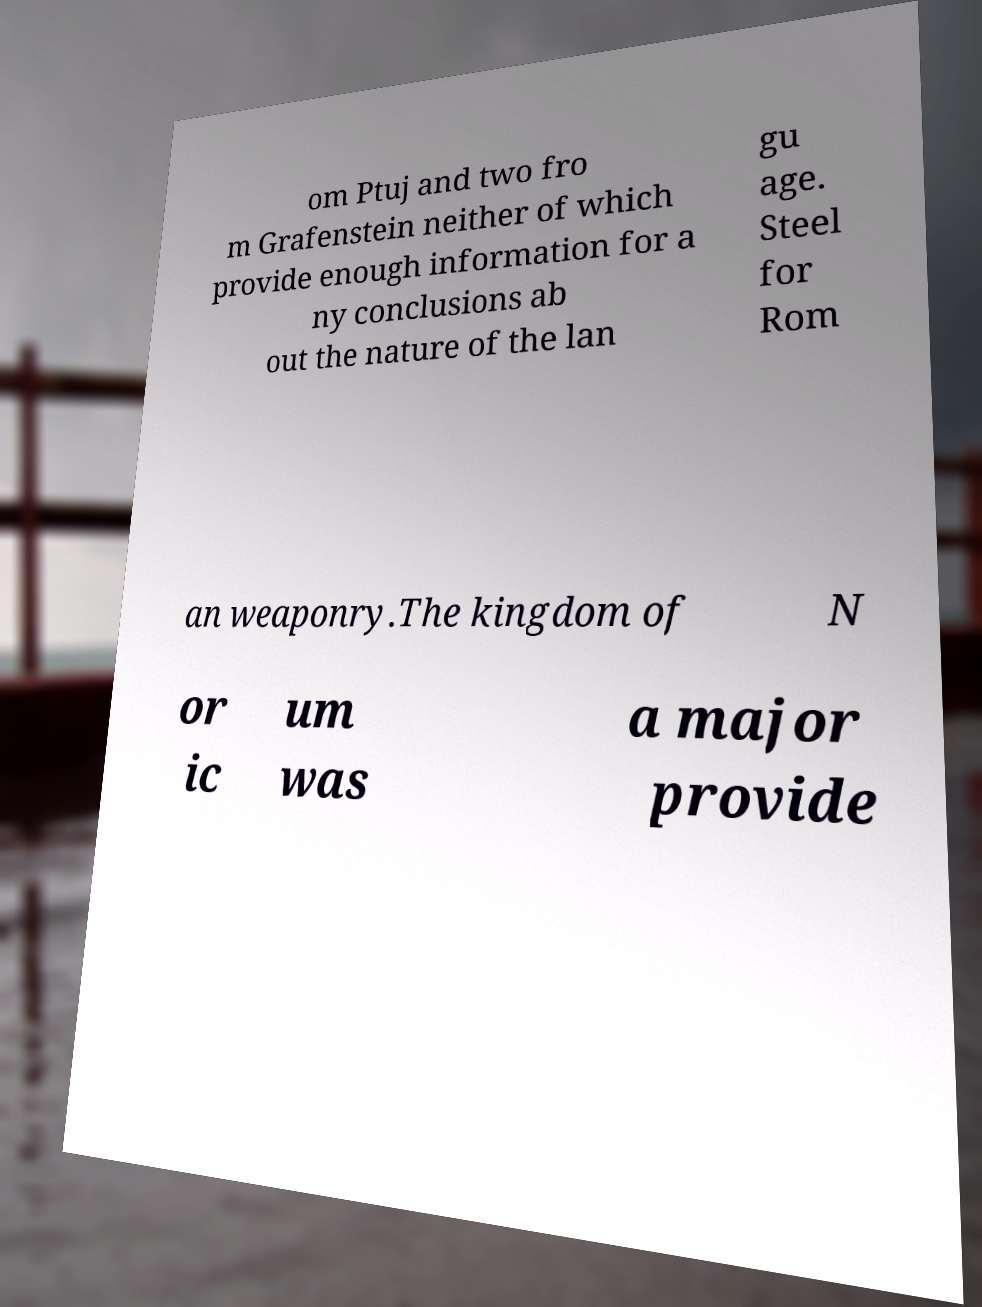Could you assist in decoding the text presented in this image and type it out clearly? om Ptuj and two fro m Grafenstein neither of which provide enough information for a ny conclusions ab out the nature of the lan gu age. Steel for Rom an weaponry.The kingdom of N or ic um was a major provide 